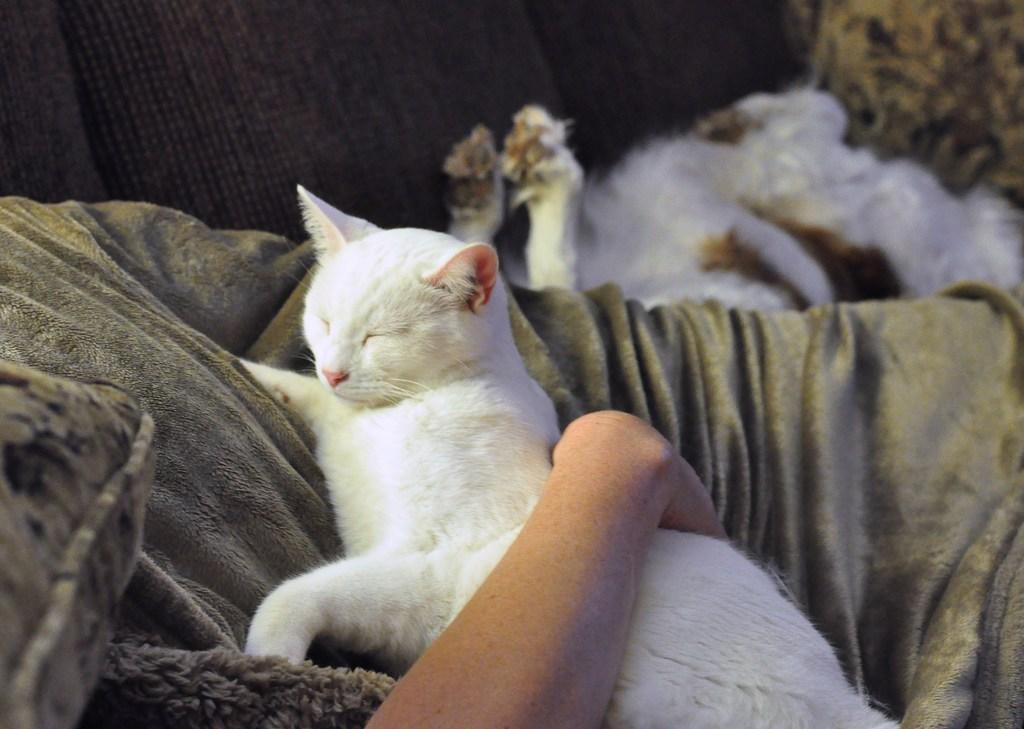What can be seen in the image that belongs to a person? There is a person's hand in the image. What is the person's hand holding? The hand is holding a white color cat. Where is the cat laying in the image? The cat is laying on a bed sheet. What type of furniture is visible in the image? There is a couch visible in the image. What type of tent can be seen in the image? There is no tent present in the image. What type of work is the person doing with the cat in the image? The image does not show the person performing any work with the cat; they are simply holding it. 